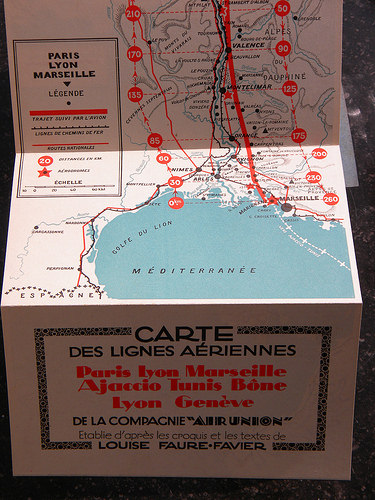<image>
Is there a star above the sea? Yes. The star is positioned above the sea in the vertical space, higher up in the scene. 